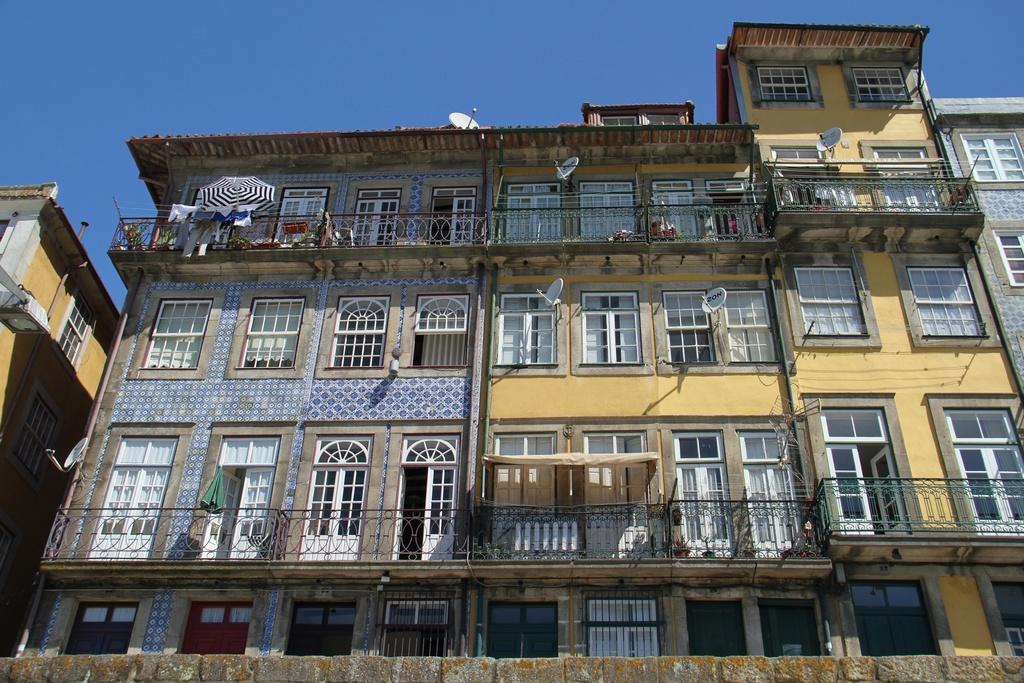How would you summarize this image in a sentence or two? In this picture there is a building in the center of the image, on which there are many windows. 